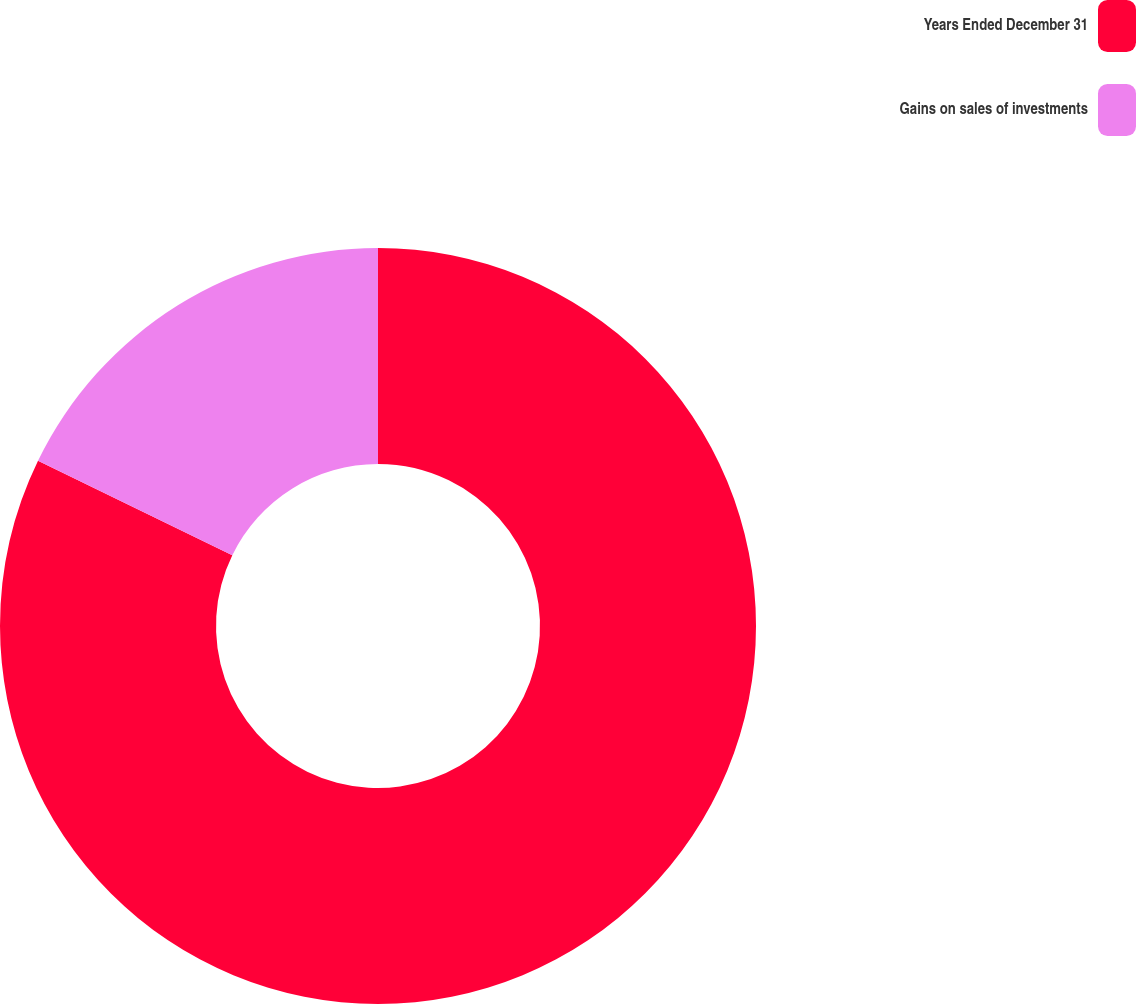<chart> <loc_0><loc_0><loc_500><loc_500><pie_chart><fcel>Years Ended December 31<fcel>Gains on sales of investments<nl><fcel>82.2%<fcel>17.8%<nl></chart> 